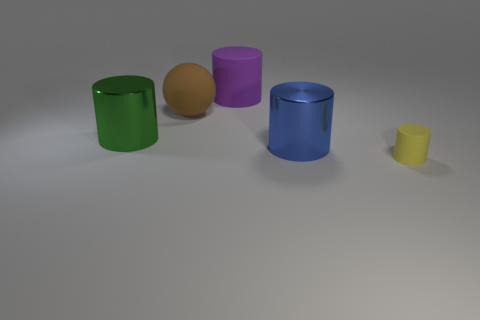There is a matte object that is in front of the metallic cylinder that is left of the cylinder behind the green shiny thing; what is its size?
Offer a terse response. Small. There is a purple thing; is it the same shape as the big metallic object right of the green shiny object?
Offer a very short reply. Yes. How many other things are the same size as the purple matte thing?
Offer a terse response. 3. What size is the metal cylinder on the right side of the big green cylinder?
Provide a succinct answer. Large. What number of yellow blocks are made of the same material as the big purple cylinder?
Give a very brief answer. 0. There is a big thing behind the large brown sphere; is it the same shape as the big brown object?
Provide a succinct answer. No. The brown rubber thing on the right side of the green cylinder has what shape?
Offer a terse response. Sphere. What material is the tiny cylinder?
Offer a very short reply. Rubber. What color is the rubber sphere that is the same size as the blue metallic thing?
Provide a short and direct response. Brown. Does the tiny yellow matte thing have the same shape as the large brown object?
Your response must be concise. No. 